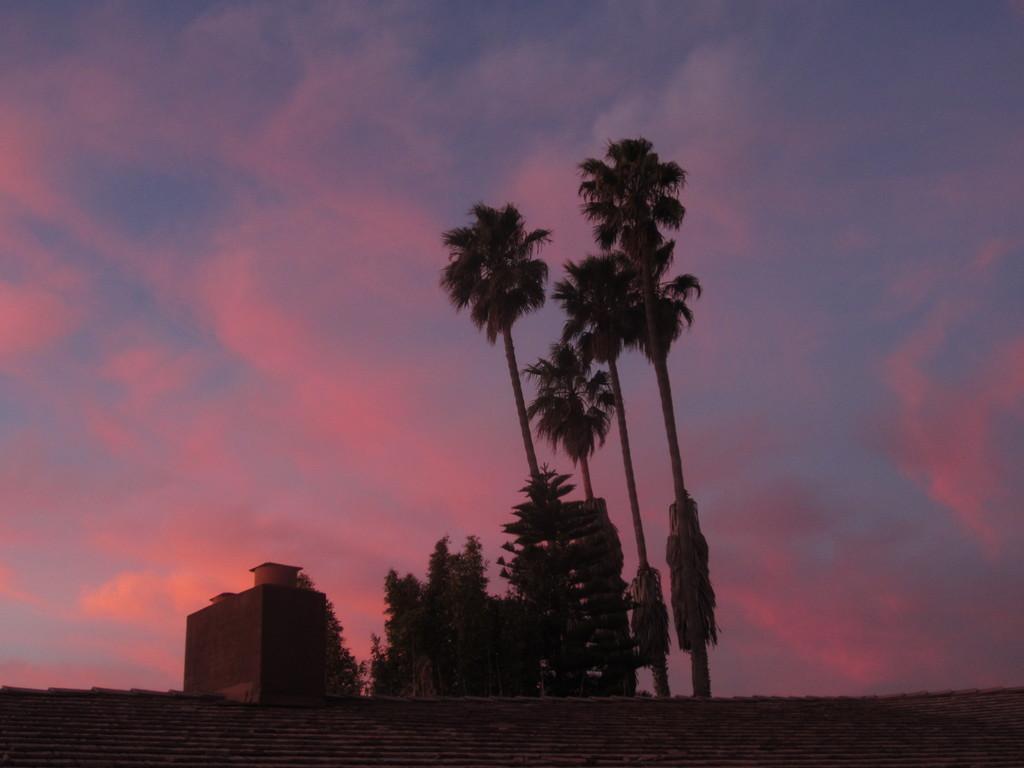Can you describe this image briefly? In this picture we can see the wall, building, trees and in the background we can see the sky with clouds. 